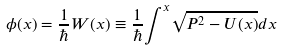Convert formula to latex. <formula><loc_0><loc_0><loc_500><loc_500>\phi ( x ) = \frac { 1 } { \hbar } { W } ( x ) \equiv \frac { 1 } { \hbar } { \int } ^ { x } \sqrt { P ^ { 2 } - U ( x ) } d x</formula> 